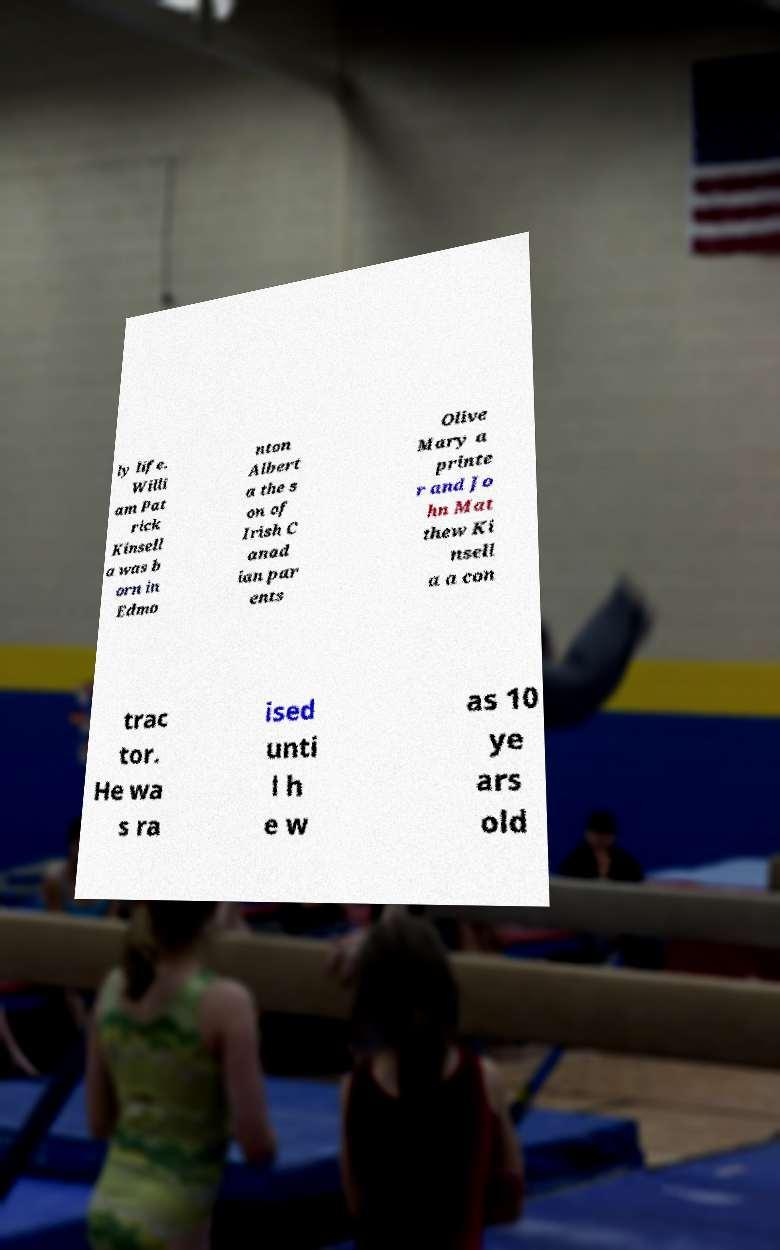Please identify and transcribe the text found in this image. ly life. Willi am Pat rick Kinsell a was b orn in Edmo nton Albert a the s on of Irish C anad ian par ents Olive Mary a printe r and Jo hn Mat thew Ki nsell a a con trac tor. He wa s ra ised unti l h e w as 10 ye ars old 